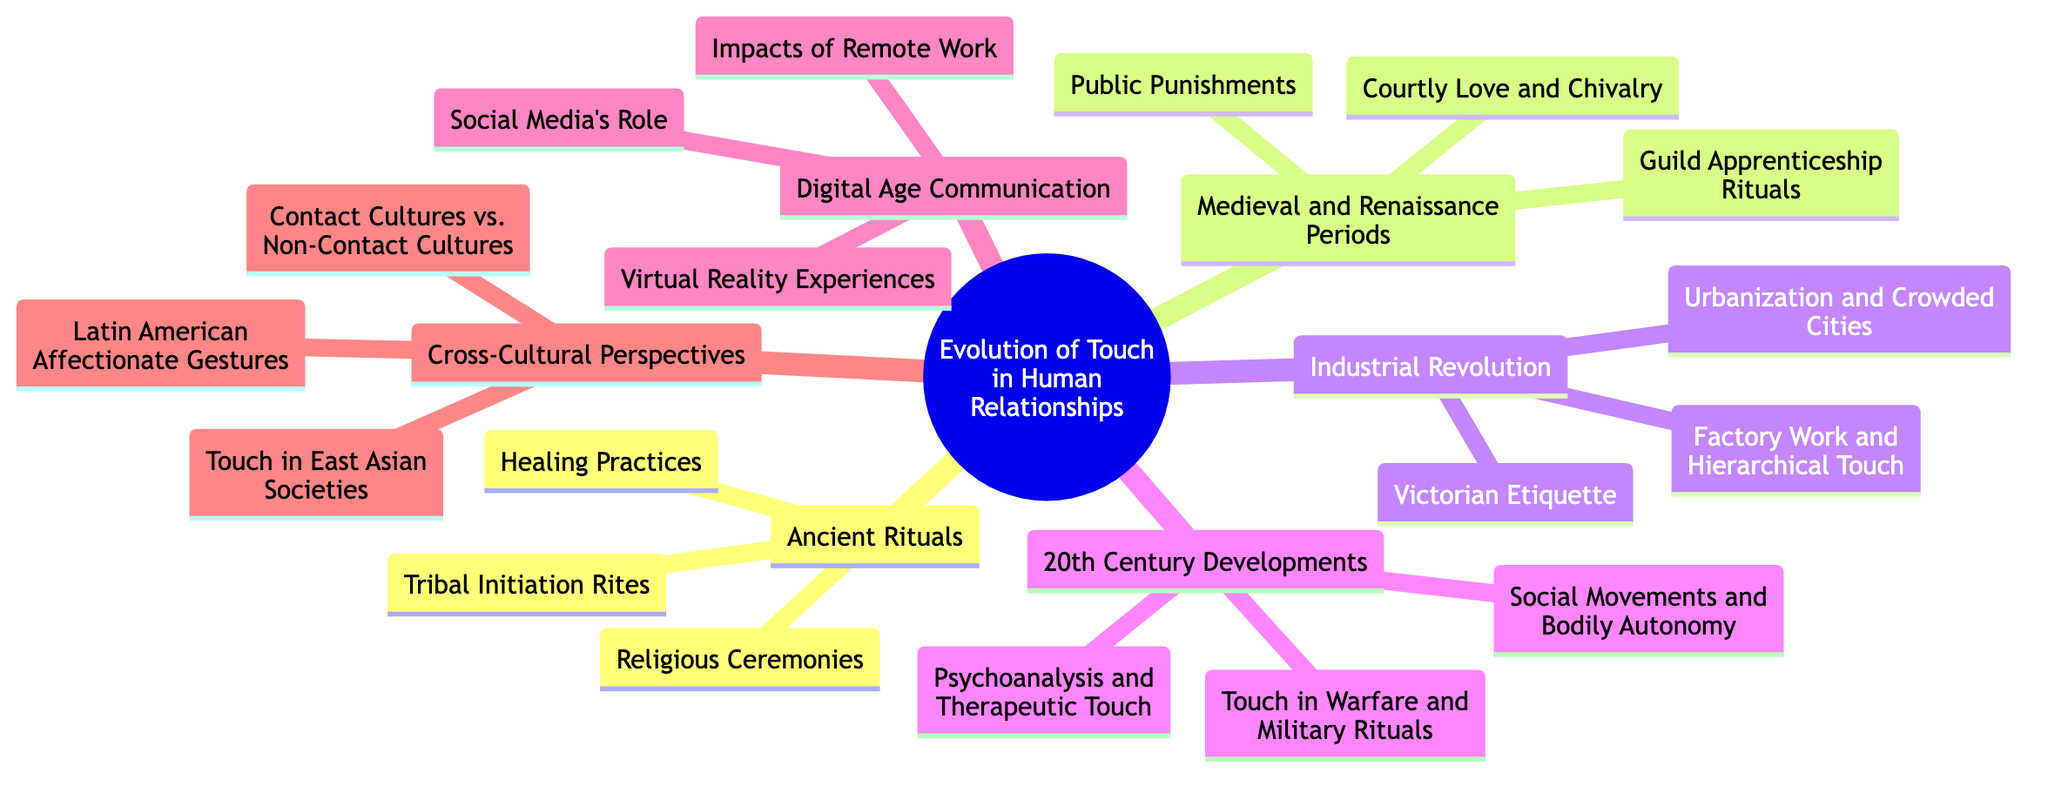What are the three elements listed under Ancient Rituals? The diagram shows three elements listed under Ancient Rituals: Religious Ceremonies, Healing Practices, and Tribal Initiation Rites.
Answer: Religious Ceremonies, Healing Practices, Tribal Initiation Rites How many subtopics are listed under 20th Century Developments? The 20th Century Developments subtopic has three elements listed: Psychoanalysis and Therapeutic Touch, Touch in Warfare and Military Rituals, and Social Movements and Bodily Autonomy. Therefore, there are three subtopics.
Answer: 3 Which subtopic discusses the concept of Victorian Etiquette? The concept of Victorian Etiquette is listed under the Industrial Revolution, as reflected in the subtopics of this section.
Answer: Industrial Revolution What is the main topic of the mind map? The main topic of the mind map is clearly stated at the root of the diagram. It is focused on the Evolution of Touch in Human Relationships.
Answer: Evolution of Touch in Human Relationships What distinguishes Contact Cultures from Non-Contact Cultures in this diagram? The Cross-Cultural Perspectives subtopic addresses this distinction by comparing Contact Cultures vs. Non-Contact Cultures. It indicates a thematic focus on how different cultures perceive and use touch.
Answer: Contact Cultures vs. Non-Contact Cultures 